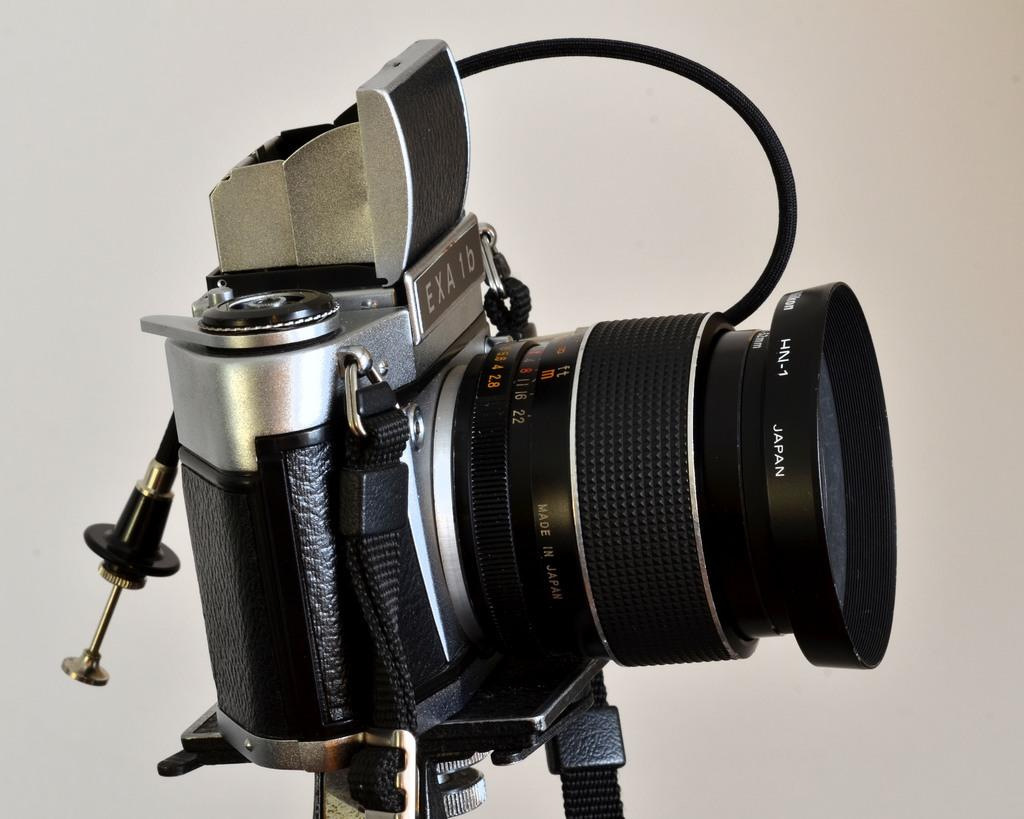What is the main object in the image? There is a camera in the image. How is the camera positioned in the image? The camera is on a stand. What color is the camera? The camera is black and grey in color. What is the background of the image look like? The background of the image is white. Can you hear the governor speaking in the image? There is no governor or any sound in the image, as it is a still photograph of a camera on a stand with a white background. 